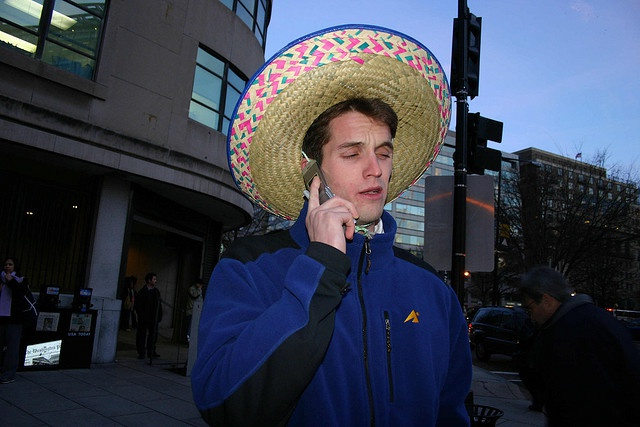Describe the objects in this image and their specific colors. I can see people in teal, navy, black, tan, and gray tones, people in black and teal tones, car in teal, black, navy, darkblue, and maroon tones, traffic light in teal, black, navy, blue, and gray tones, and people in teal, black, navy, purple, and darkblue tones in this image. 